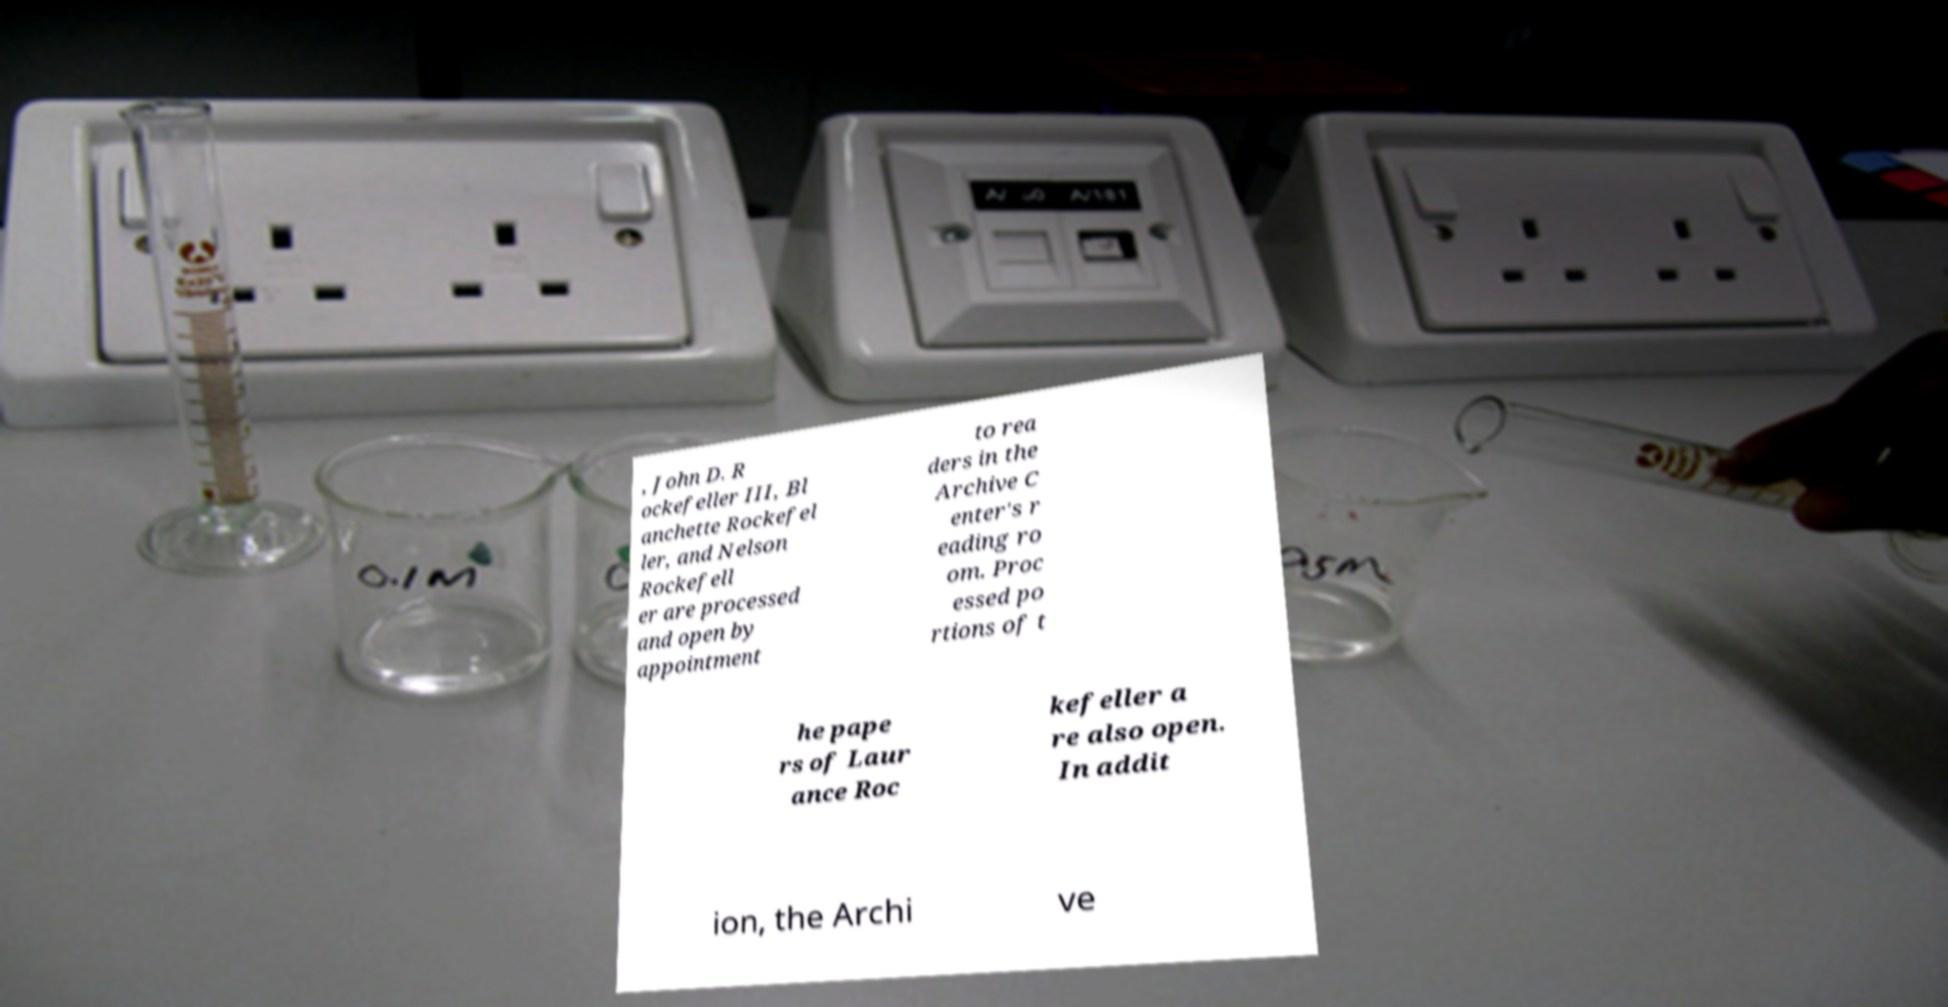There's text embedded in this image that I need extracted. Can you transcribe it verbatim? , John D. R ockefeller III, Bl anchette Rockefel ler, and Nelson Rockefell er are processed and open by appointment to rea ders in the Archive C enter's r eading ro om. Proc essed po rtions of t he pape rs of Laur ance Roc kefeller a re also open. In addit ion, the Archi ve 